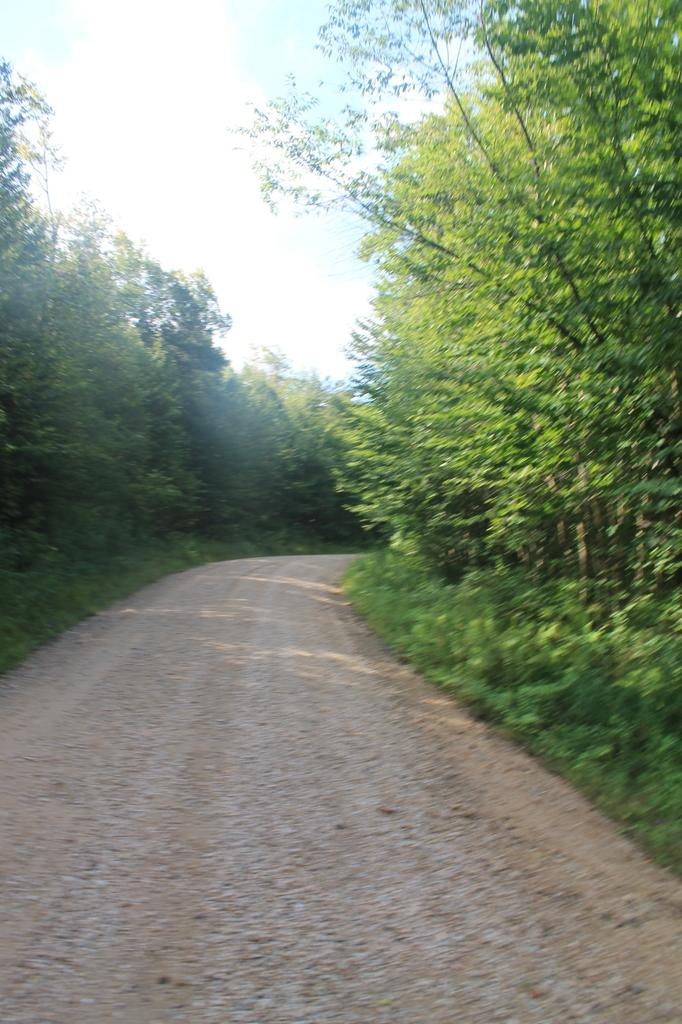What is the main feature of the image? There is a road in the image. What can be seen on both sides of the road? There are trees on both sides of the road. What is the condition of the sky in the image? The sky is clear and visible in the image. Can you tell me how many people are attending the event in the image? There is no event or person present in the image; it only features a road with trees on both sides and a clear sky. What type of hole can be seen in the image? There is no hole present in the image. 